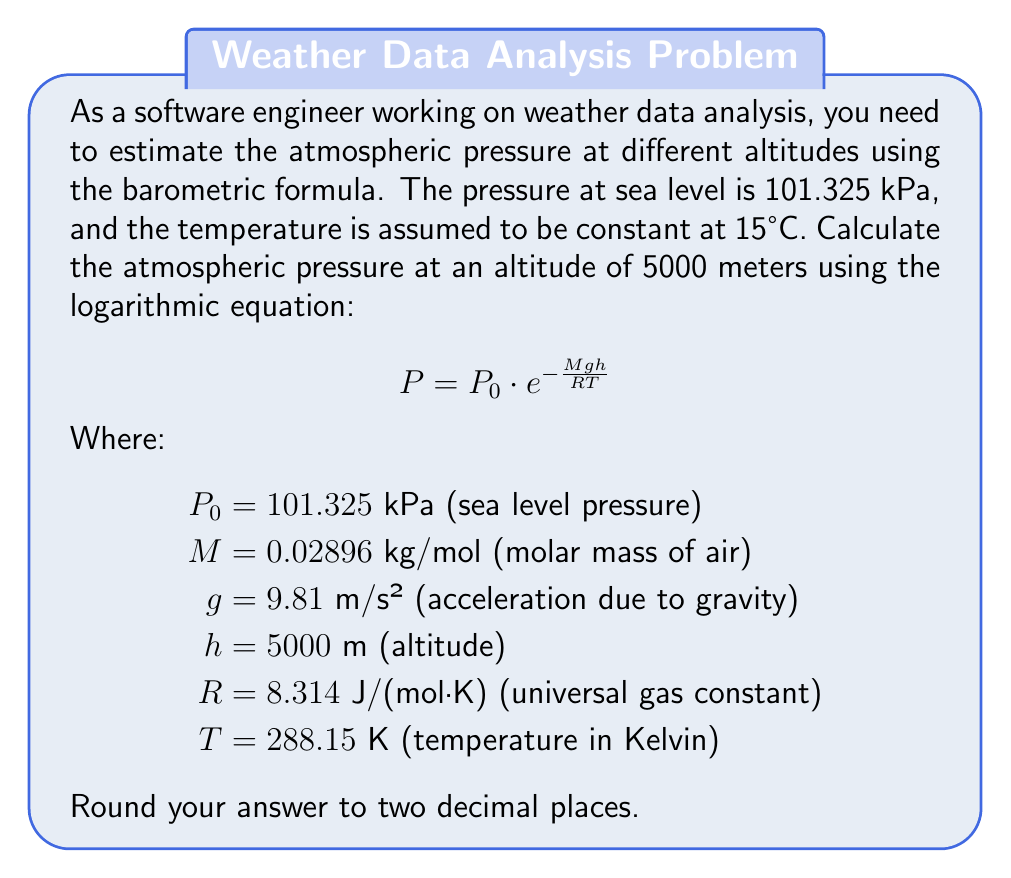Can you answer this question? To solve this problem, we'll follow these steps:

1. Identify the given values:
   $P_0 = 101.325$ kPa
   $M = 0.02896$ kg/mol
   $g = 9.81$ m/s²
   $h = 5000$ m
   $R = 8.314$ J/(mol·K)
   $T = 288.15$ K

2. Substitute these values into the barometric formula:
   $$P = 101.325 \cdot e^{-\frac{0.02896 \cdot 9.81 \cdot 5000}{8.314 \cdot 288.15}}$$

3. Calculate the exponent:
   $$\frac{0.02896 \cdot 9.81 \cdot 5000}{8.314 \cdot 288.15} = 0.5787$$

4. Simplify the equation:
   $$P = 101.325 \cdot e^{-0.5787}$$

5. Calculate the result:
   $$P = 101.325 \cdot 0.5607 = 56.81 \text{ kPa}$$

6. Round to two decimal places:
   $$P \approx 56.81 \text{ kPa}$$

This result shows that the atmospheric pressure at an altitude of 5000 meters is approximately 56.81 kPa, which is about 56% of the pressure at sea level.
Answer: 56.81 kPa 